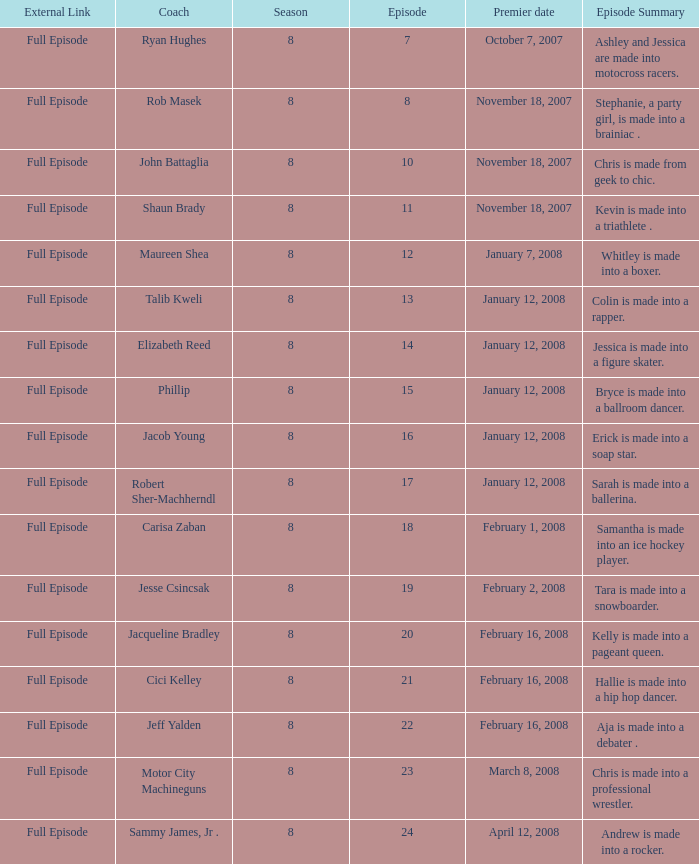What coach premiered February 16, 2008 later than episode 21.0? Jeff Yalden. 